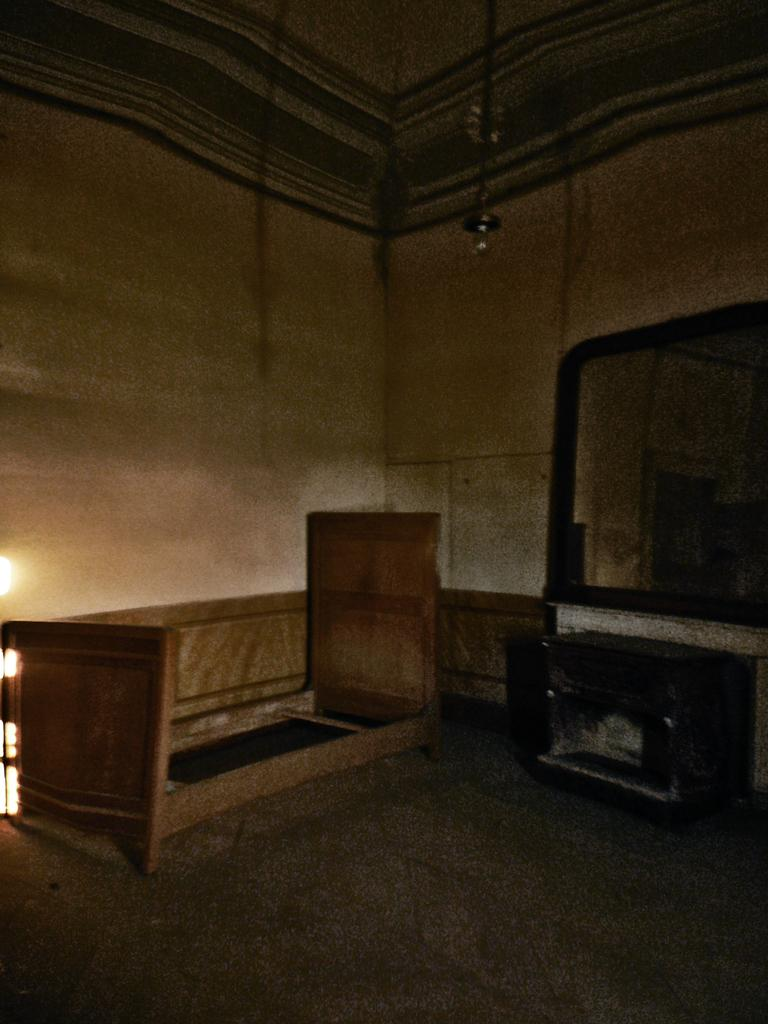What type of object is located in the left corner of the image? There is a wooden object in the left corner of the image. What can be found in the right corner of the image? There is a mirror in the right corner of the image. Is there any source of light visible in the image? Yes, there is a bulb above the mirror in the image. Can you see a fight between two animals in the image? No, there is no fight between two animals present in the image. Is there a twig visible in the image? No, there is no twig visible in the image. 